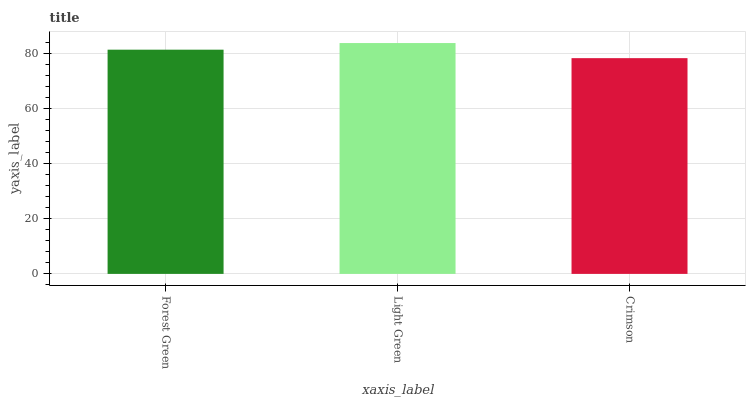Is Light Green the minimum?
Answer yes or no. No. Is Crimson the maximum?
Answer yes or no. No. Is Light Green greater than Crimson?
Answer yes or no. Yes. Is Crimson less than Light Green?
Answer yes or no. Yes. Is Crimson greater than Light Green?
Answer yes or no. No. Is Light Green less than Crimson?
Answer yes or no. No. Is Forest Green the high median?
Answer yes or no. Yes. Is Forest Green the low median?
Answer yes or no. Yes. Is Crimson the high median?
Answer yes or no. No. Is Crimson the low median?
Answer yes or no. No. 